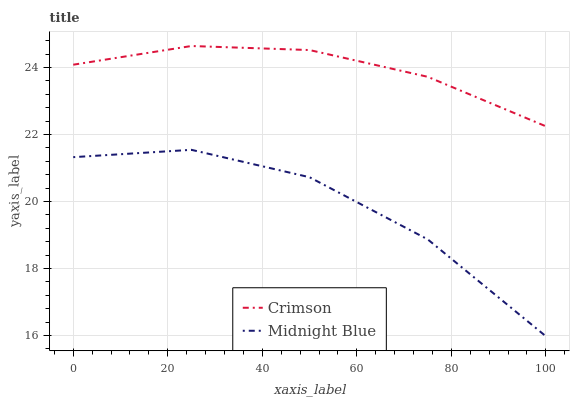Does Midnight Blue have the minimum area under the curve?
Answer yes or no. Yes. Does Crimson have the maximum area under the curve?
Answer yes or no. Yes. Does Midnight Blue have the maximum area under the curve?
Answer yes or no. No. Is Crimson the smoothest?
Answer yes or no. Yes. Is Midnight Blue the roughest?
Answer yes or no. Yes. Is Midnight Blue the smoothest?
Answer yes or no. No. Does Midnight Blue have the lowest value?
Answer yes or no. Yes. Does Crimson have the highest value?
Answer yes or no. Yes. Does Midnight Blue have the highest value?
Answer yes or no. No. Is Midnight Blue less than Crimson?
Answer yes or no. Yes. Is Crimson greater than Midnight Blue?
Answer yes or no. Yes. Does Midnight Blue intersect Crimson?
Answer yes or no. No. 